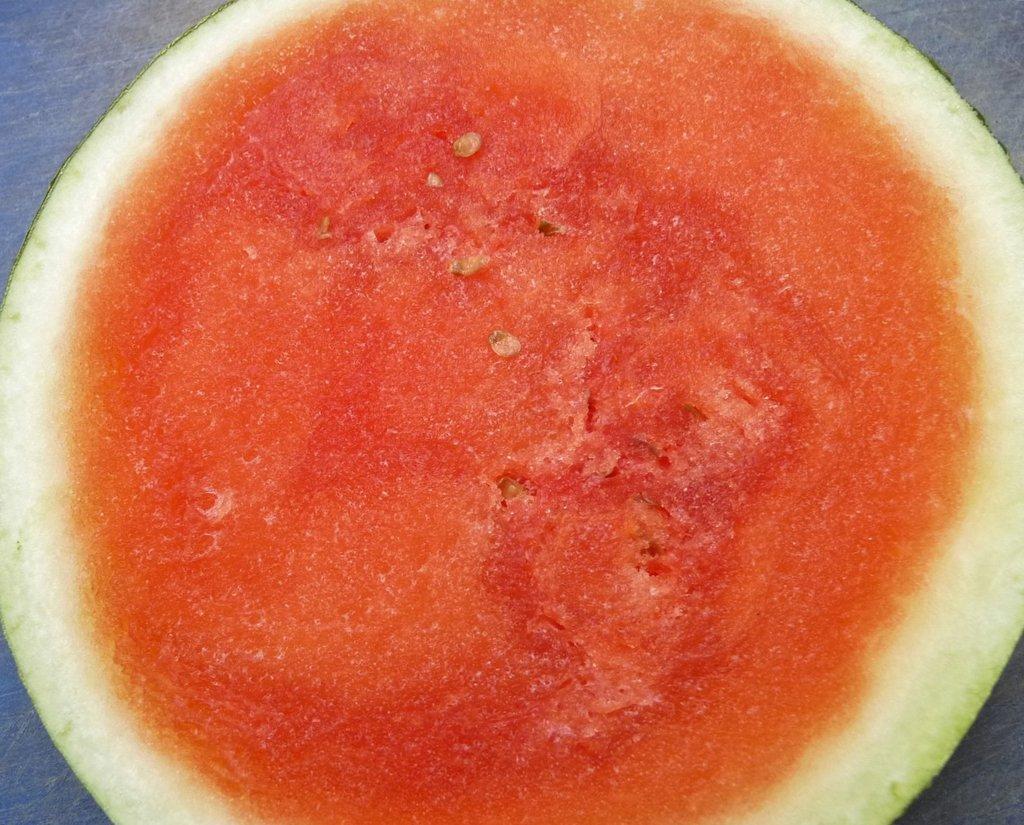Can you describe this image briefly? In the image we can see a piece of watermelon. 